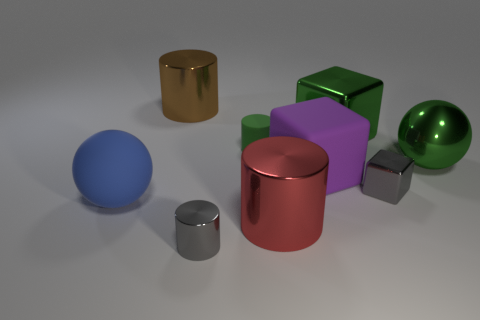Subtract all yellow cylinders. Subtract all blue blocks. How many cylinders are left? 4 Add 1 metallic cylinders. How many objects exist? 10 Subtract all balls. How many objects are left? 7 Subtract 0 purple spheres. How many objects are left? 9 Subtract all big cyan balls. Subtract all cylinders. How many objects are left? 5 Add 5 large rubber balls. How many large rubber balls are left? 6 Add 5 big green metal cylinders. How many big green metal cylinders exist? 5 